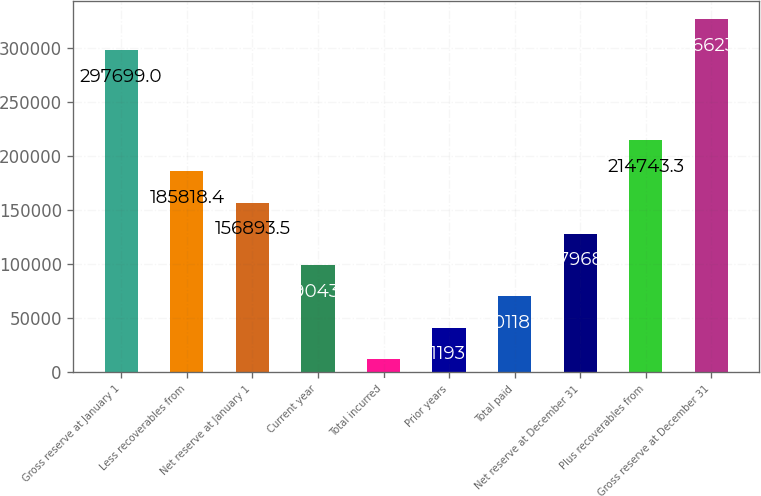<chart> <loc_0><loc_0><loc_500><loc_500><bar_chart><fcel>Gross reserve at January 1<fcel>Less recoverables from<fcel>Net reserve at January 1<fcel>Current year<fcel>Total incurred<fcel>Prior years<fcel>Total paid<fcel>Net reserve at December 31<fcel>Plus recoverables from<fcel>Gross reserve at December 31<nl><fcel>297699<fcel>185818<fcel>156894<fcel>99043.7<fcel>12269<fcel>41193.9<fcel>70118.8<fcel>127969<fcel>214743<fcel>326624<nl></chart> 